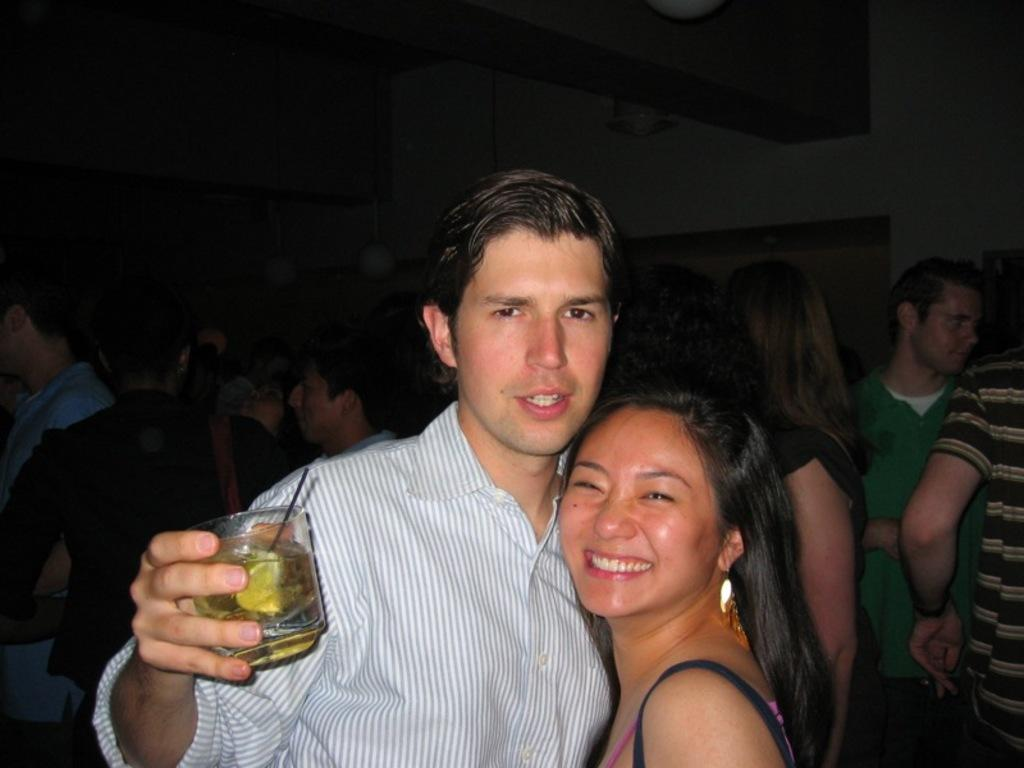How many individuals are present in the image? There are 2 people in the image. What is the person on the left holding? The person on the left is holding a glass of drink. Can you describe the surroundings of the two people? There are other people visible in the background. What type of jam is being used as bait in the image? There is no jam or bait present in the image. How much debt is visible in the image? There is no reference to debt in the image. 